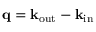<formula> <loc_0><loc_0><loc_500><loc_500>{ q } = { k } _ { o u t } - { k } _ { i n }</formula> 